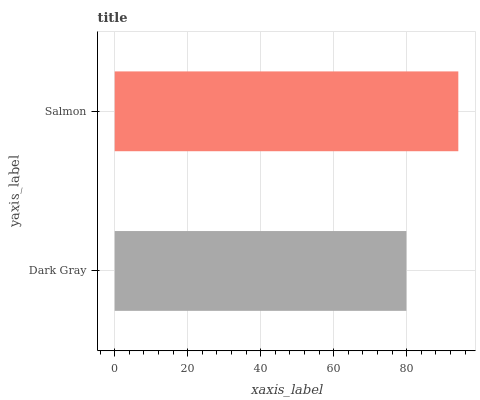Is Dark Gray the minimum?
Answer yes or no. Yes. Is Salmon the maximum?
Answer yes or no. Yes. Is Salmon the minimum?
Answer yes or no. No. Is Salmon greater than Dark Gray?
Answer yes or no. Yes. Is Dark Gray less than Salmon?
Answer yes or no. Yes. Is Dark Gray greater than Salmon?
Answer yes or no. No. Is Salmon less than Dark Gray?
Answer yes or no. No. Is Salmon the high median?
Answer yes or no. Yes. Is Dark Gray the low median?
Answer yes or no. Yes. Is Dark Gray the high median?
Answer yes or no. No. Is Salmon the low median?
Answer yes or no. No. 